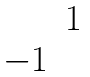<formula> <loc_0><loc_0><loc_500><loc_500>\begin{matrix} & 1 \\ - 1 & \end{matrix}</formula> 